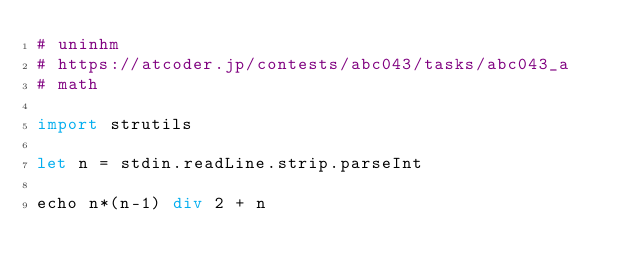<code> <loc_0><loc_0><loc_500><loc_500><_Nim_># uninhm
# https://atcoder.jp/contests/abc043/tasks/abc043_a
# math

import strutils

let n = stdin.readLine.strip.parseInt

echo n*(n-1) div 2 + n
</code> 